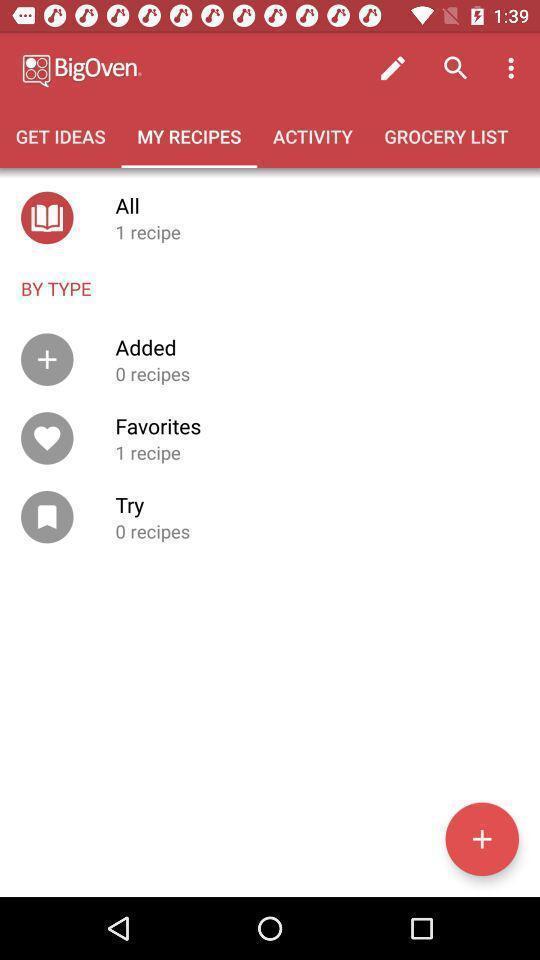Please provide a description for this image. Screen showing my recipes page of a food app. 